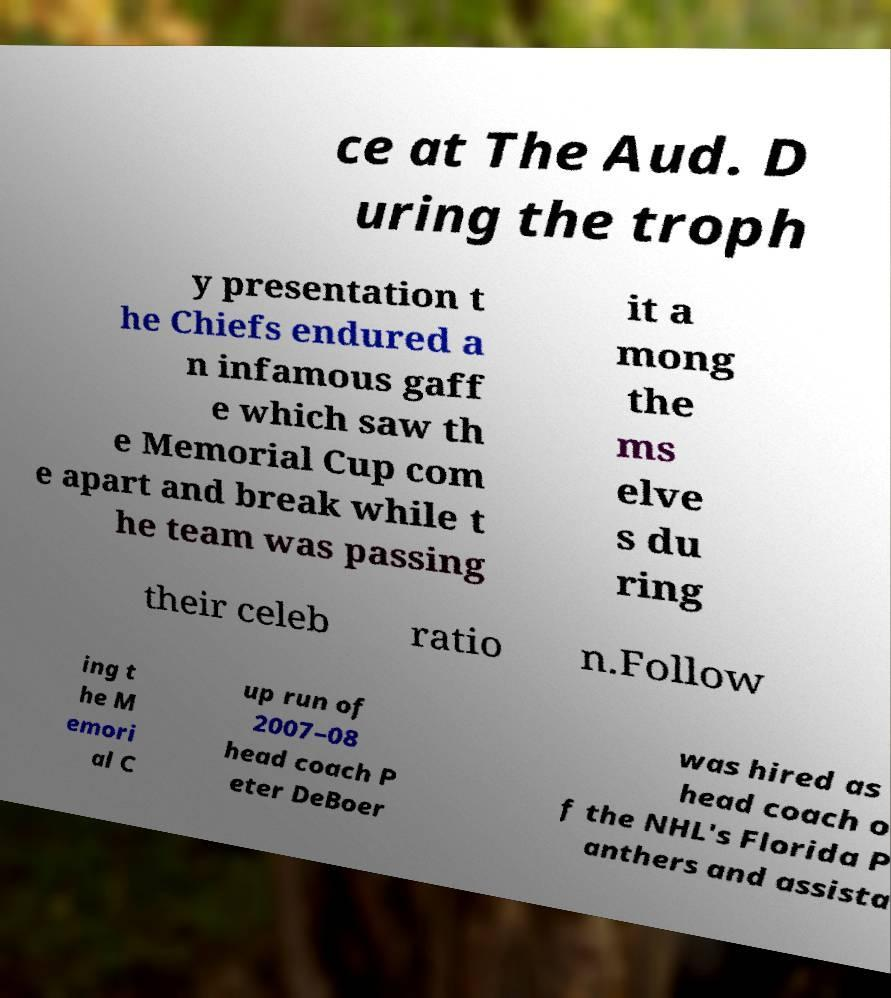Can you read and provide the text displayed in the image?This photo seems to have some interesting text. Can you extract and type it out for me? ce at The Aud. D uring the troph y presentation t he Chiefs endured a n infamous gaff e which saw th e Memorial Cup com e apart and break while t he team was passing it a mong the ms elve s du ring their celeb ratio n.Follow ing t he M emori al C up run of 2007–08 head coach P eter DeBoer was hired as head coach o f the NHL's Florida P anthers and assista 